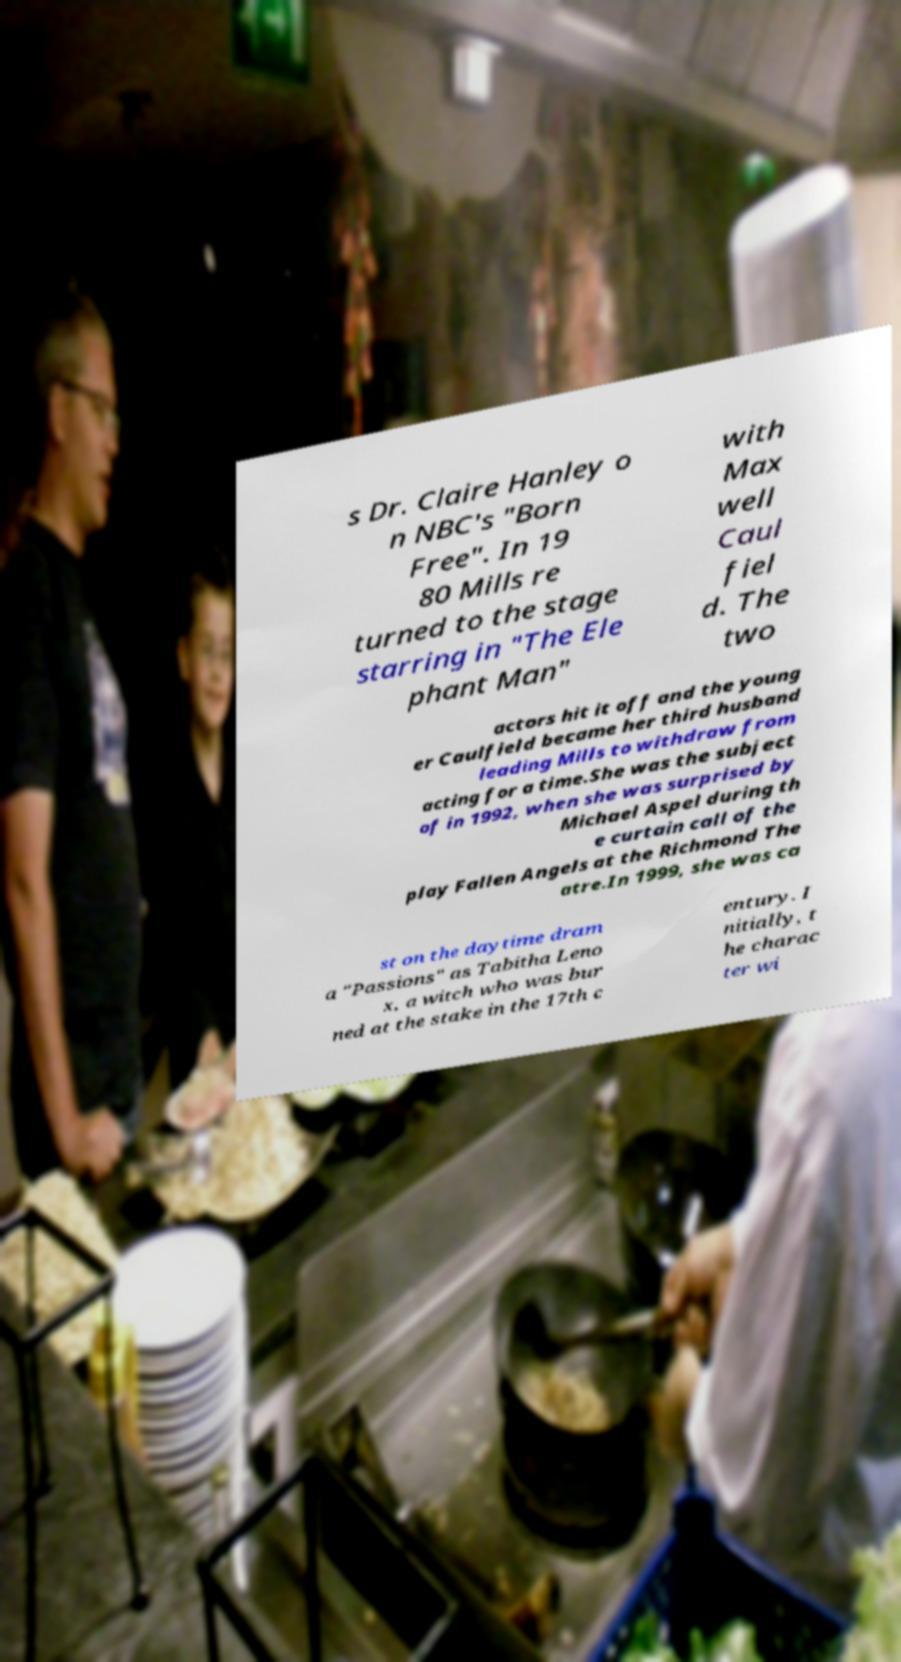For documentation purposes, I need the text within this image transcribed. Could you provide that? s Dr. Claire Hanley o n NBC's "Born Free". In 19 80 Mills re turned to the stage starring in "The Ele phant Man" with Max well Caul fiel d. The two actors hit it off and the young er Caulfield became her third husband leading Mills to withdraw from acting for a time.She was the subject of in 1992, when she was surprised by Michael Aspel during th e curtain call of the play Fallen Angels at the Richmond The atre.In 1999, she was ca st on the daytime dram a "Passions" as Tabitha Leno x, a witch who was bur ned at the stake in the 17th c entury. I nitially, t he charac ter wi 